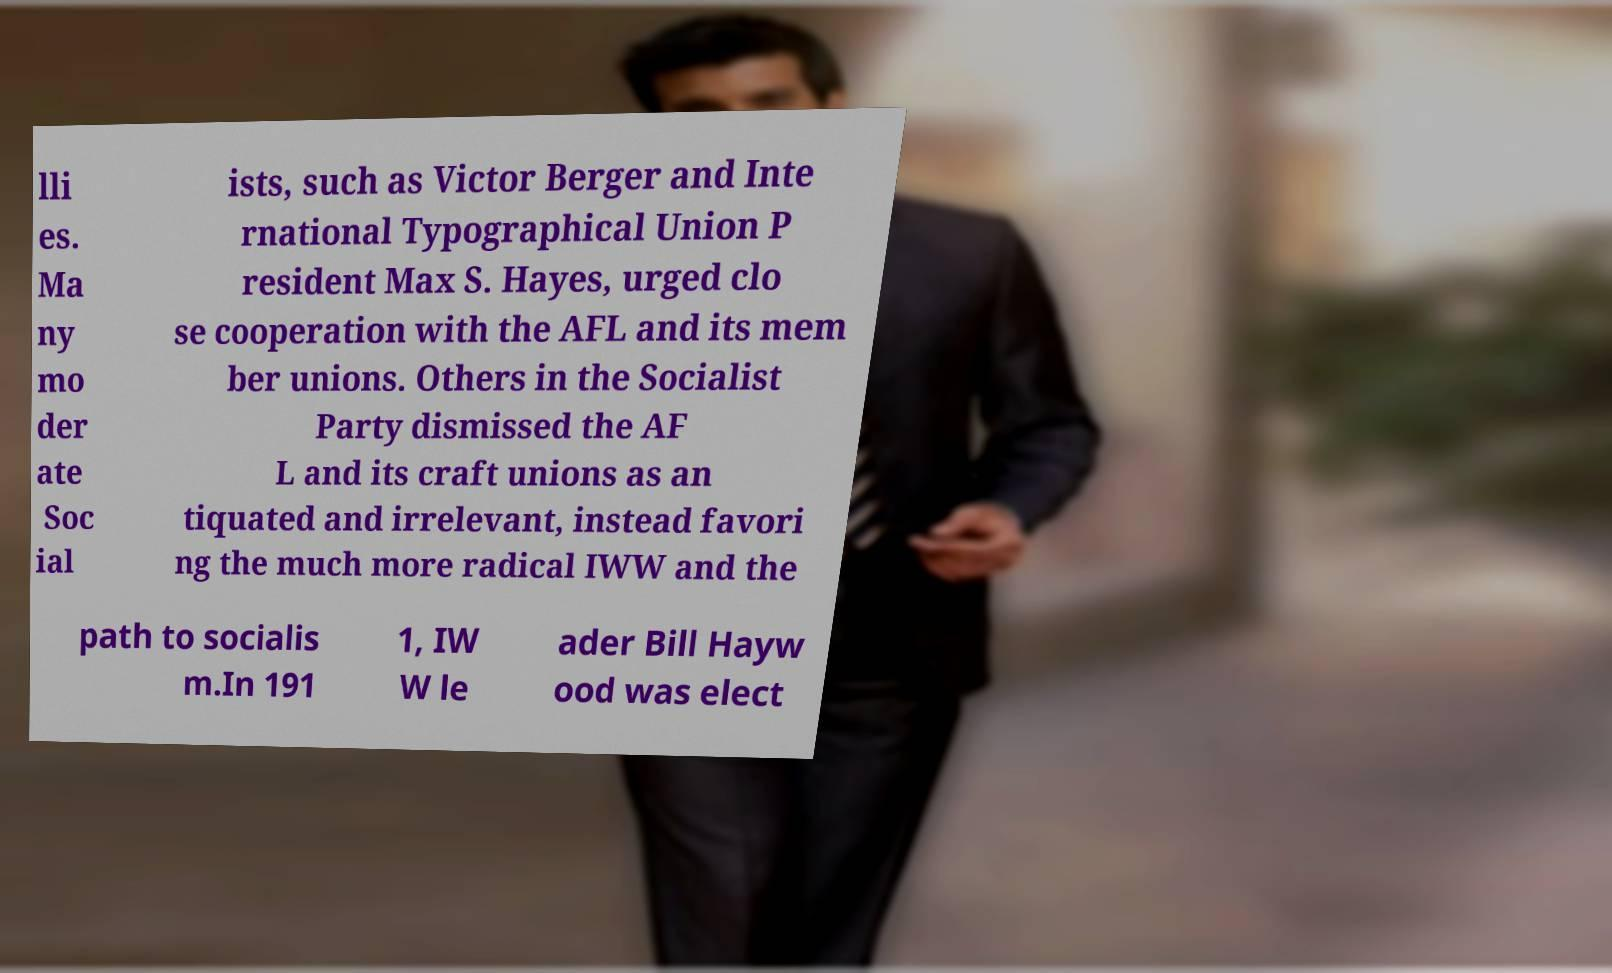Please identify and transcribe the text found in this image. lli es. Ma ny mo der ate Soc ial ists, such as Victor Berger and Inte rnational Typographical Union P resident Max S. Hayes, urged clo se cooperation with the AFL and its mem ber unions. Others in the Socialist Party dismissed the AF L and its craft unions as an tiquated and irrelevant, instead favori ng the much more radical IWW and the path to socialis m.In 191 1, IW W le ader Bill Hayw ood was elect 